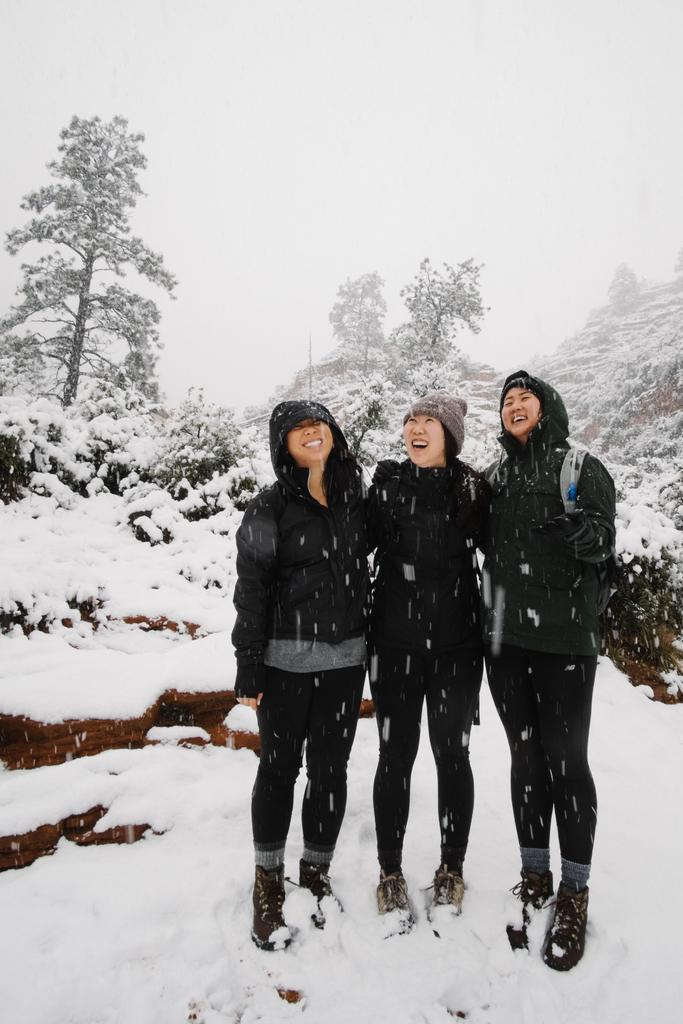How many people are in the image? There are three persons in the image. What color are the outfits worn by the persons in the image? The persons are wearing black-colored outfits. What type of terrain is visible in the image? The persons are standing on snow, which is also visible in the background of the image. What can be seen in the background of the image besides the snow? There are trees and the sky visible in the background of the image. How does the increase in nerve cells affect the image? There is no mention of nerve cells or any biological processes in the image, so this question cannot be answered. 